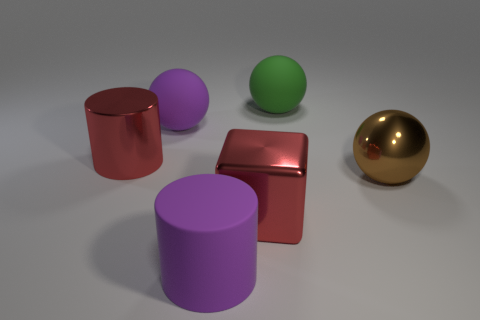If these objects were part of a set, what kind of set do you think it could be? These objects could be part of a designer's toolkit for modeling and rendering. They serve as perfect examples to showcase different materials, shapes, and colors, commonly used for testing in 3D design and computer graphics. 